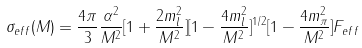<formula> <loc_0><loc_0><loc_500><loc_500>\sigma _ { e f f } ( M ) = \frac { 4 \pi } { 3 } \frac { \alpha ^ { 2 } } { M ^ { 2 } } [ 1 + \frac { 2 m _ { l } ^ { 2 } } { M ^ { 2 } } ] [ 1 - \frac { 4 m _ { l } ^ { 2 } } { M ^ { 2 } } ] ^ { 1 / 2 } [ 1 - \frac { 4 m _ { \pi } ^ { 2 } } { M ^ { 2 } } ] F _ { e f f }</formula> 